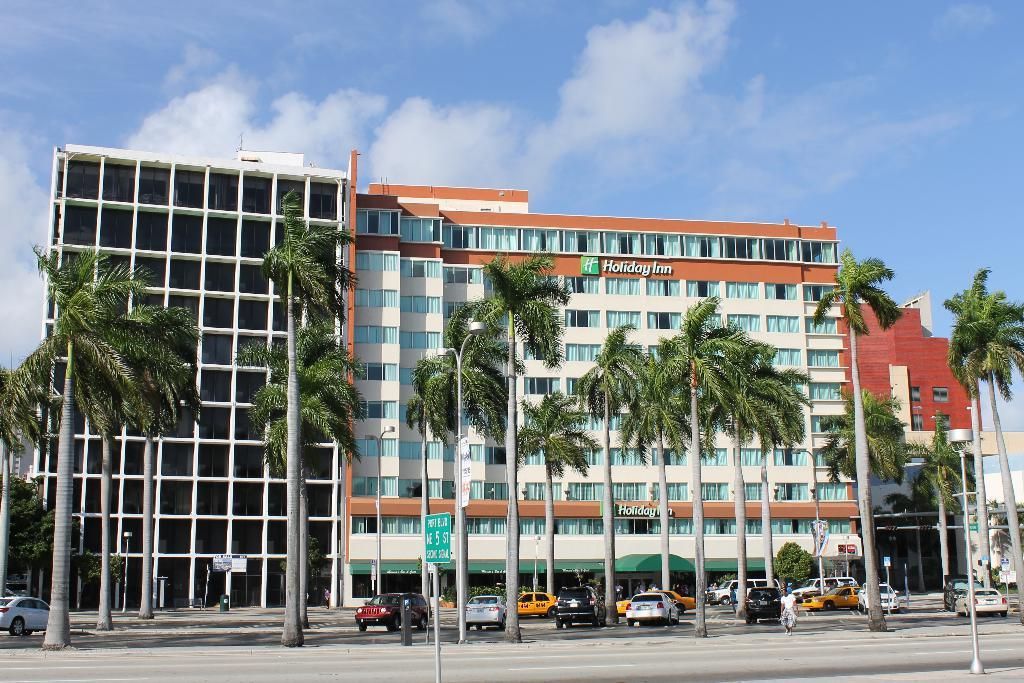What type of vehicles can be seen in the image? There are cars in the image. What other objects are present alongside the cars? There are poles in the image. Where are the cars and poles located in the image? The cars and poles are at the bottom side of the image. What type of vegetation is visible in the image? There are trees in the image. Where are the trees located in the image? The trees are in the center of the image. What type of structures can be seen in the background of the image? There are buildings in the image. Where are the buildings located in the image? The buildings are in the background area of the image. What type of flesh can be seen on the cars in the image? There is no flesh present on the cars in the image; they are vehicles made of metal and other materials. 